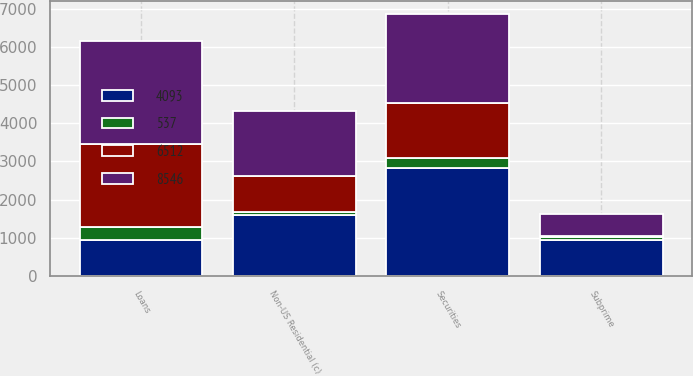Convert chart to OTSL. <chart><loc_0><loc_0><loc_500><loc_500><stacked_bar_chart><ecel><fcel>Subprime<fcel>Non-US Residential (c)<fcel>Securities<fcel>Loans<nl><fcel>8546<fcel>569<fcel>1702<fcel>2337<fcel>2699<nl><fcel>4093<fcel>941<fcel>1591<fcel>2836<fcel>951<nl><fcel>6512<fcel>28<fcel>951<fcel>1438<fcel>2179<nl><fcel>537<fcel>76<fcel>86<fcel>257<fcel>333<nl></chart> 